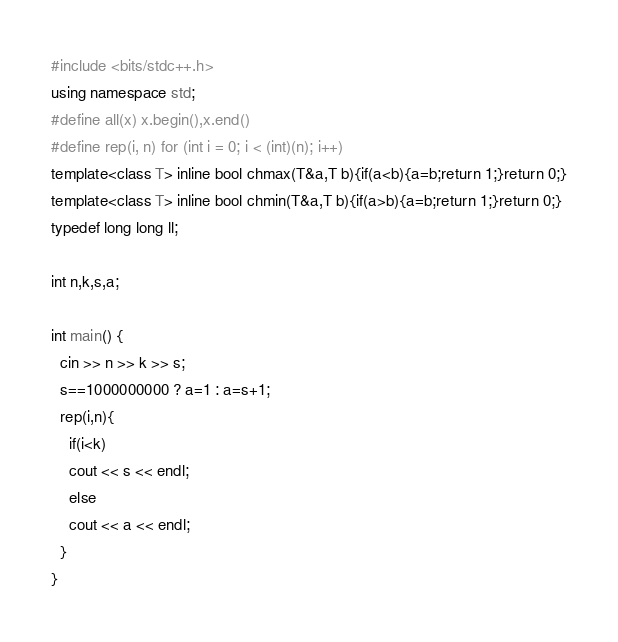<code> <loc_0><loc_0><loc_500><loc_500><_C++_>#include <bits/stdc++.h>
using namespace std;
#define all(x) x.begin(),x.end()
#define rep(i, n) for (int i = 0; i < (int)(n); i++)
template<class T> inline bool chmax(T&a,T b){if(a<b){a=b;return 1;}return 0;}
template<class T> inline bool chmin(T&a,T b){if(a>b){a=b;return 1;}return 0;}
typedef long long ll;

int n,k,s,a;

int main() {
  cin >> n >> k >> s;
  s==1000000000 ? a=1 : a=s+1;
  rep(i,n){
    if(i<k)
    cout << s << endl;
    else    
    cout << a << endl;
  }
}</code> 